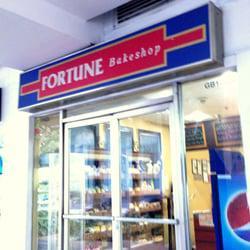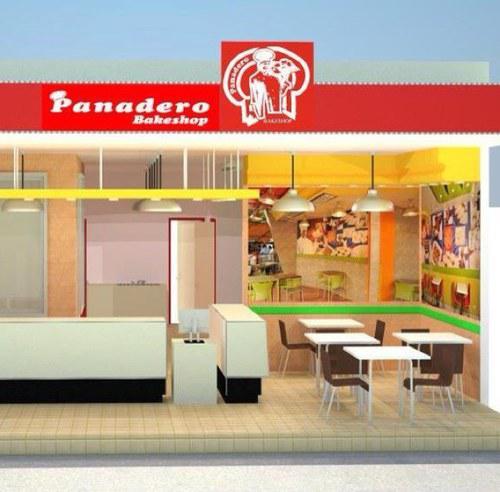The first image is the image on the left, the second image is the image on the right. Analyze the images presented: Is the assertion "These stores feature different names in each image of the set." valid? Answer yes or no. Yes. 